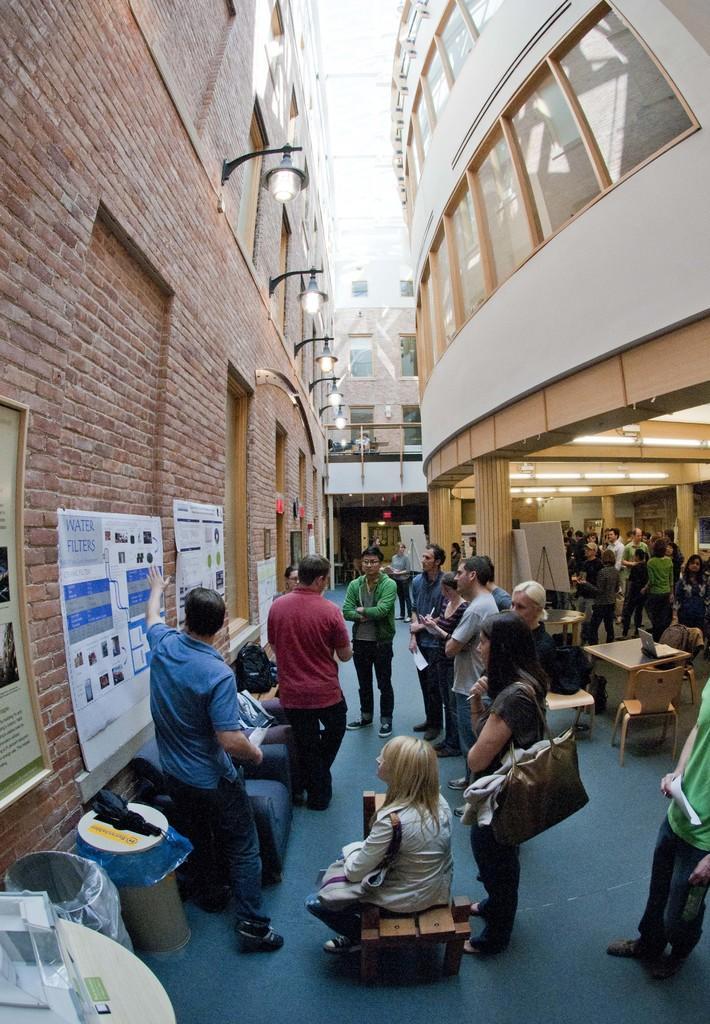Please provide a concise description of this image. In this picture I can see buildings and few lights fixed to the wall and I can see a woman sitting on the bench and few people standing and I can see chairs, tables and there are few posters and a frame on the wall with some text and I can see couple of dustbins. 